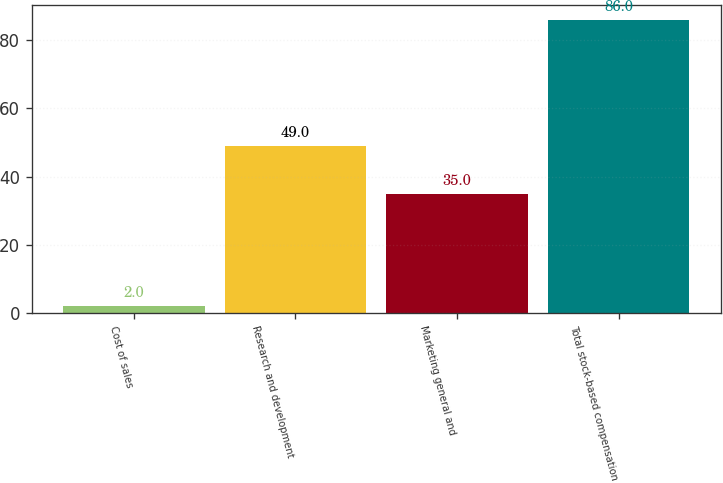<chart> <loc_0><loc_0><loc_500><loc_500><bar_chart><fcel>Cost of sales<fcel>Research and development<fcel>Marketing general and<fcel>Total stock-based compensation<nl><fcel>2<fcel>49<fcel>35<fcel>86<nl></chart> 